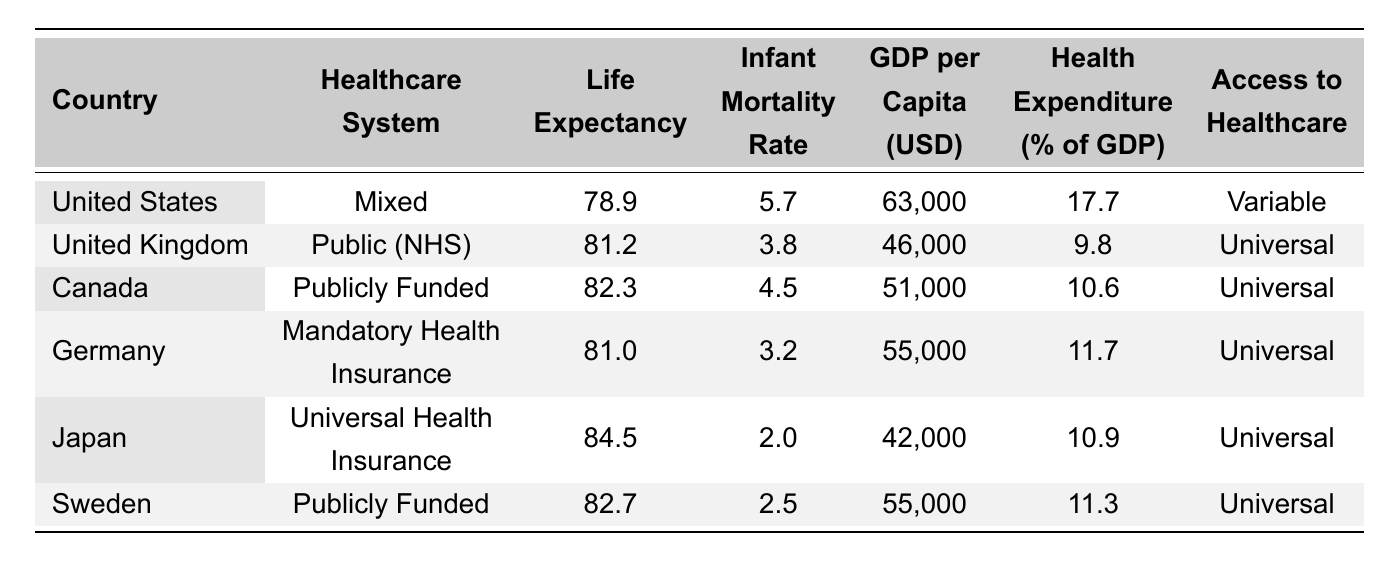What is the life expectancy of Japan? The table shows the life expectancy for Japan listed in the corresponding row, which is 84.5 years.
Answer: 84.5 Which country has the highest GDP per capita? By comparing the GDP per capita values in the table, the United States has the highest at 63,000 USD.
Answer: United States What is the difference in life expectancy between Canada and the United Kingdom? The life expectancy in Canada is 82.3 years and in the UK, it is 81.2 years. The difference is 82.3 - 81.2 = 1.1 years.
Answer: 1.1 Is it true that Sweden has the highest infant mortality rate among the countries listed? The infant mortality rate for Sweden is 2.5, while the rates for other countries are lower: Japan (2.0), Germany (3.2), UK (3.8), Canada (4.5), and US (5.7). Therefore, this statement is false.
Answer: No What is the average health expenditure percentage of GDP for the countries listed? Adding the health expenditure percentages: 17.7 + 9.8 + 10.6 + 11.7 + 10.9 + 11.3 = 71.3. There are 6 countries, so the average is 71.3 / 6 = 11.88.
Answer: 11.88 Which two countries have the same type of healthcare system? Looking at the healthcare system column, Canada and Sweden both have a "Publicly Funded" system.
Answer: Canada and Sweden What is the total GDP per capita for the countries with universal access to healthcare? The countries with universal access are the UK, Canada, Germany, Japan, and Sweden, with GDPs of 46,000, 51,000, 55,000, 42,000, and 55,000 respectively. Summing these gives 46,000 + 51,000 + 55,000 + 42,000 + 55,000 = 249,000 USD.
Answer: 249,000 Which country has the lowest life expectancy, and how does it compare to Japan's life expectancy? The country with the lowest life expectancy is the United States at 78.9 years, while Japan’s life expectancy is 84.5 years. Therefore, Japan's life expectancy is 84.5 - 78.9 = 5.6 years higher.
Answer: United States; 5.6 years higher Does a higher health expenditure percentage correlate with a lower infant mortality rate in this dataset? To determine this, we compare the health expenditure percentages with infant mortality rates in the table. For example, the US has the highest expenditure at 17.7% but the highest infant mortality at 5.7. Conversely, Japan has a lower expenditure at 10.9% but the lowest infant mortality at 2.0. This implies there is no direct correlation observed in this limited dataset.
Answer: No 